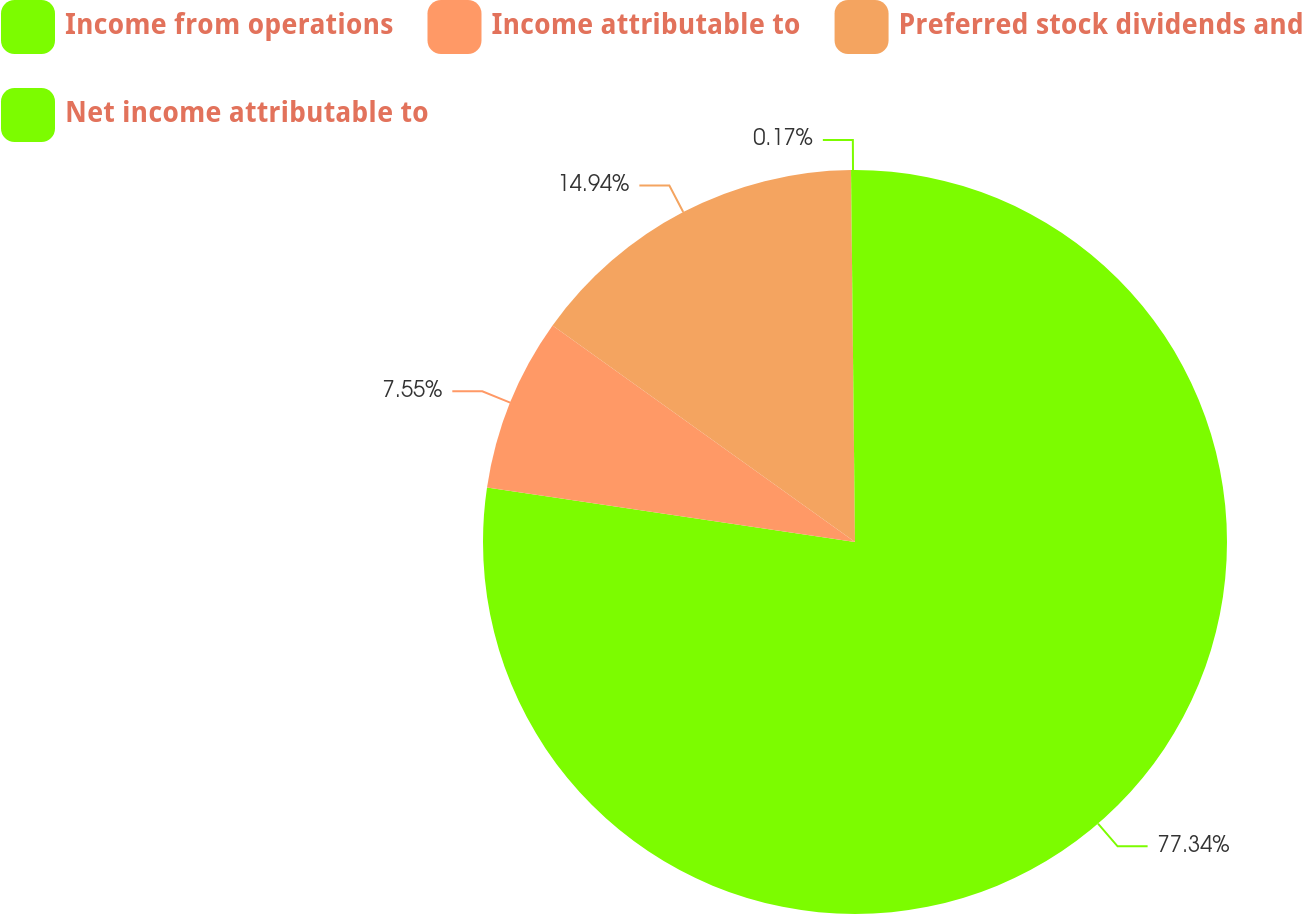Convert chart to OTSL. <chart><loc_0><loc_0><loc_500><loc_500><pie_chart><fcel>Income from operations<fcel>Income attributable to<fcel>Preferred stock dividends and<fcel>Net income attributable to<nl><fcel>77.34%<fcel>7.55%<fcel>14.94%<fcel>0.17%<nl></chart> 